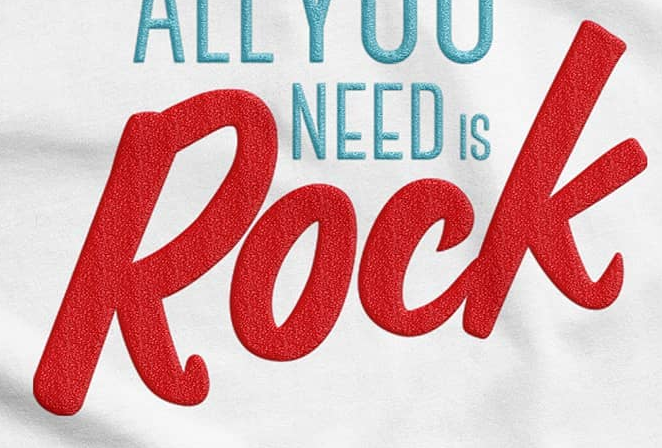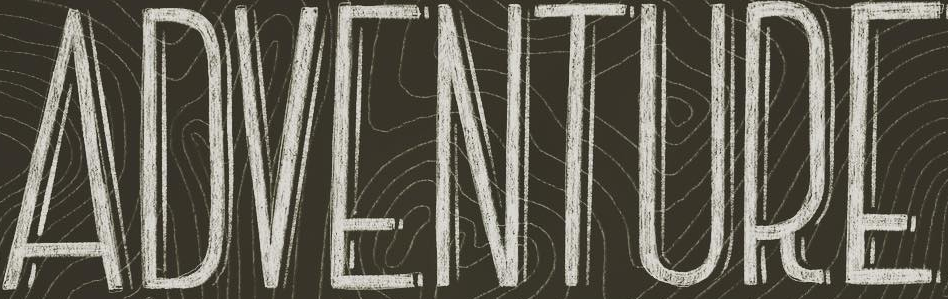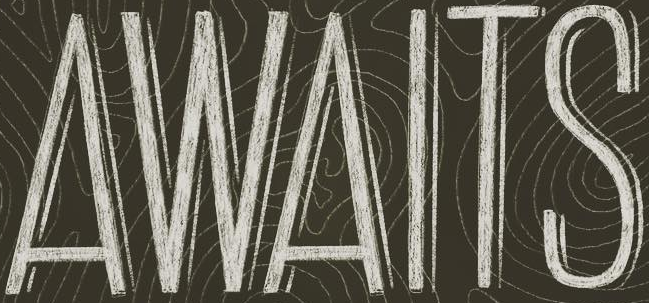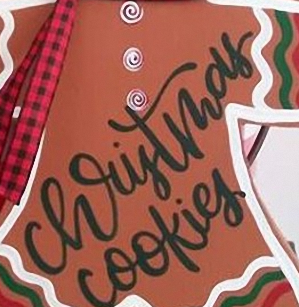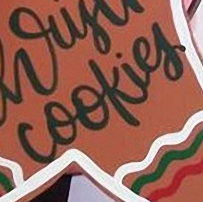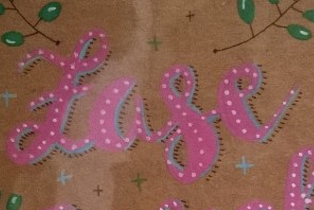What text is displayed in these images sequentially, separated by a semicolon? Rock; ADVENTURE; AWAITS; christmas; cookies; Lase 